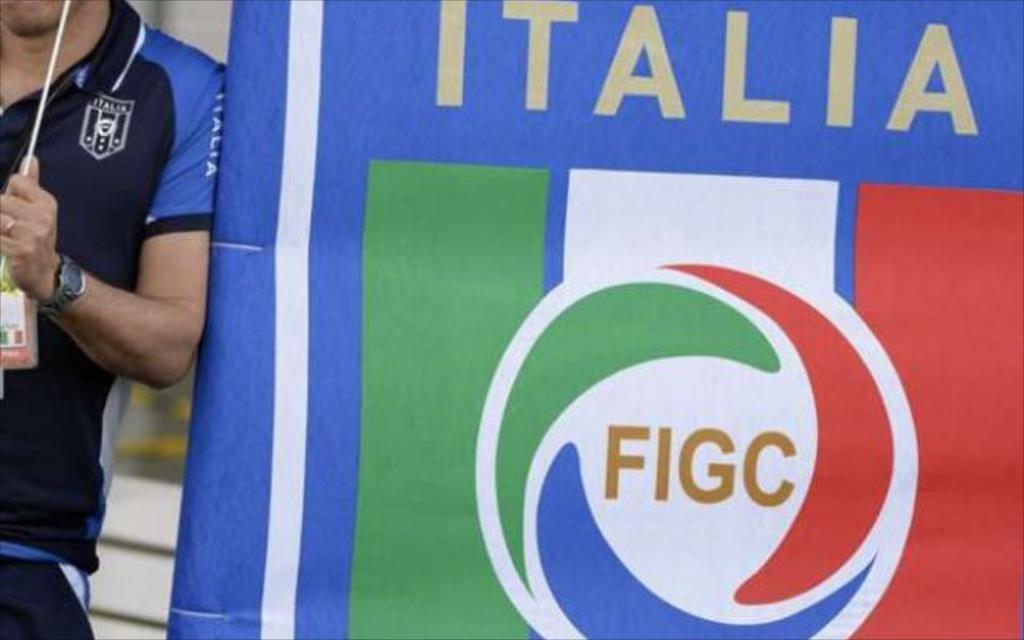What is written below the name of the country?
Ensure brevity in your answer.  Figc. 